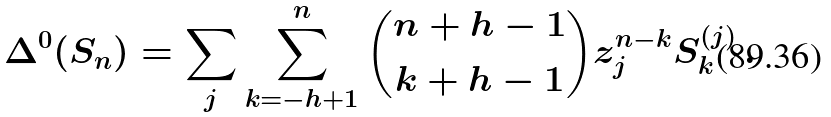Convert formula to latex. <formula><loc_0><loc_0><loc_500><loc_500>\Delta ^ { 0 } ( S _ { n } ) = \sum _ { j } \sum _ { k = - h + 1 } ^ { n } { n + h - 1 \choose k + h - 1 } z _ { j } ^ { n - k } S _ { k } ^ { ( j ) } \, .</formula> 